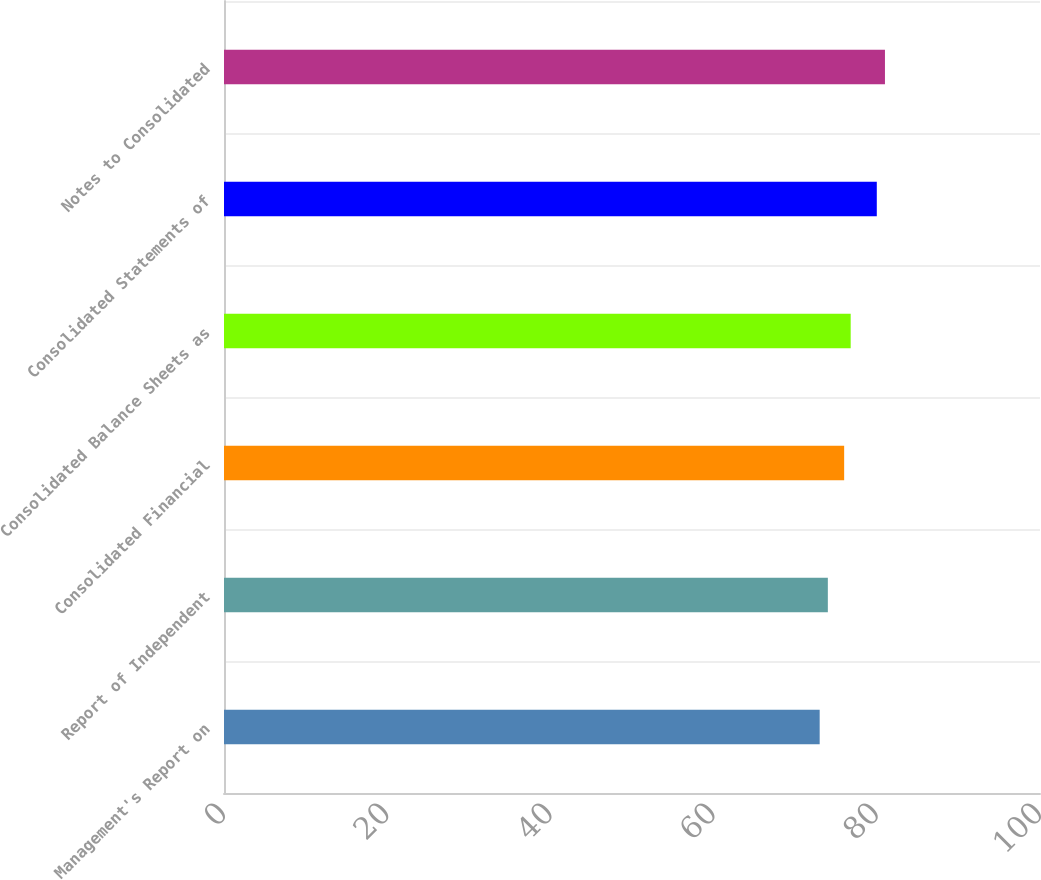<chart> <loc_0><loc_0><loc_500><loc_500><bar_chart><fcel>Management's Report on<fcel>Report of Independent<fcel>Consolidated Financial<fcel>Consolidated Balance Sheets as<fcel>Consolidated Statements of<fcel>Notes to Consolidated<nl><fcel>73<fcel>74<fcel>76<fcel>76.8<fcel>80<fcel>81<nl></chart> 